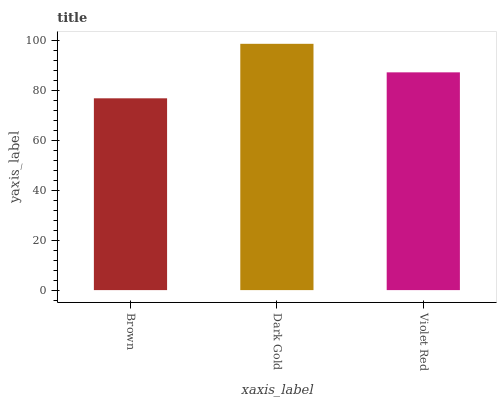Is Brown the minimum?
Answer yes or no. Yes. Is Dark Gold the maximum?
Answer yes or no. Yes. Is Violet Red the minimum?
Answer yes or no. No. Is Violet Red the maximum?
Answer yes or no. No. Is Dark Gold greater than Violet Red?
Answer yes or no. Yes. Is Violet Red less than Dark Gold?
Answer yes or no. Yes. Is Violet Red greater than Dark Gold?
Answer yes or no. No. Is Dark Gold less than Violet Red?
Answer yes or no. No. Is Violet Red the high median?
Answer yes or no. Yes. Is Violet Red the low median?
Answer yes or no. Yes. Is Brown the high median?
Answer yes or no. No. Is Brown the low median?
Answer yes or no. No. 